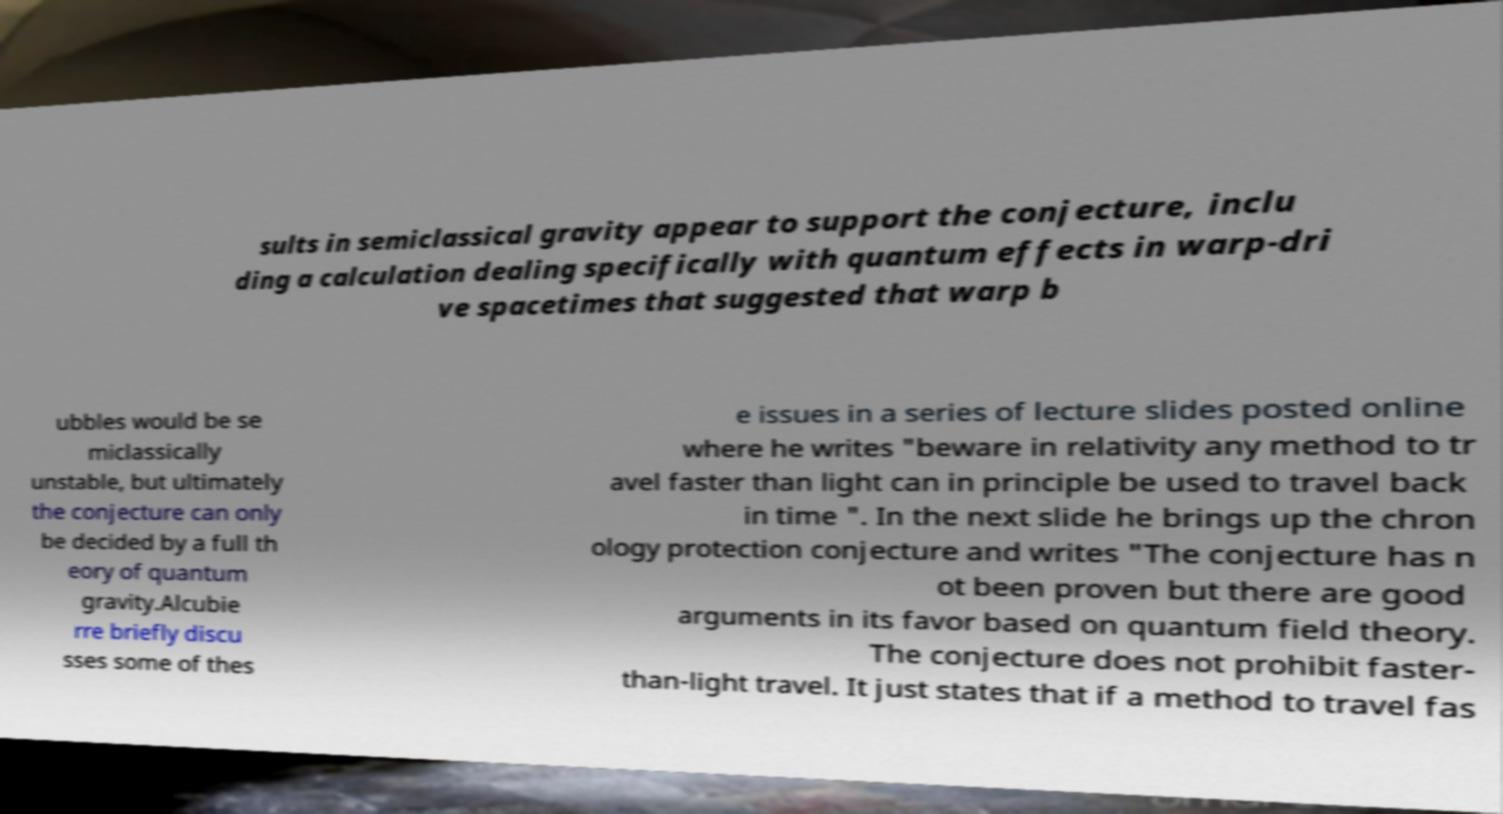Could you extract and type out the text from this image? sults in semiclassical gravity appear to support the conjecture, inclu ding a calculation dealing specifically with quantum effects in warp-dri ve spacetimes that suggested that warp b ubbles would be se miclassically unstable, but ultimately the conjecture can only be decided by a full th eory of quantum gravity.Alcubie rre briefly discu sses some of thes e issues in a series of lecture slides posted online where he writes "beware in relativity any method to tr avel faster than light can in principle be used to travel back in time ". In the next slide he brings up the chron ology protection conjecture and writes "The conjecture has n ot been proven but there are good arguments in its favor based on quantum field theory. The conjecture does not prohibit faster- than-light travel. It just states that if a method to travel fas 